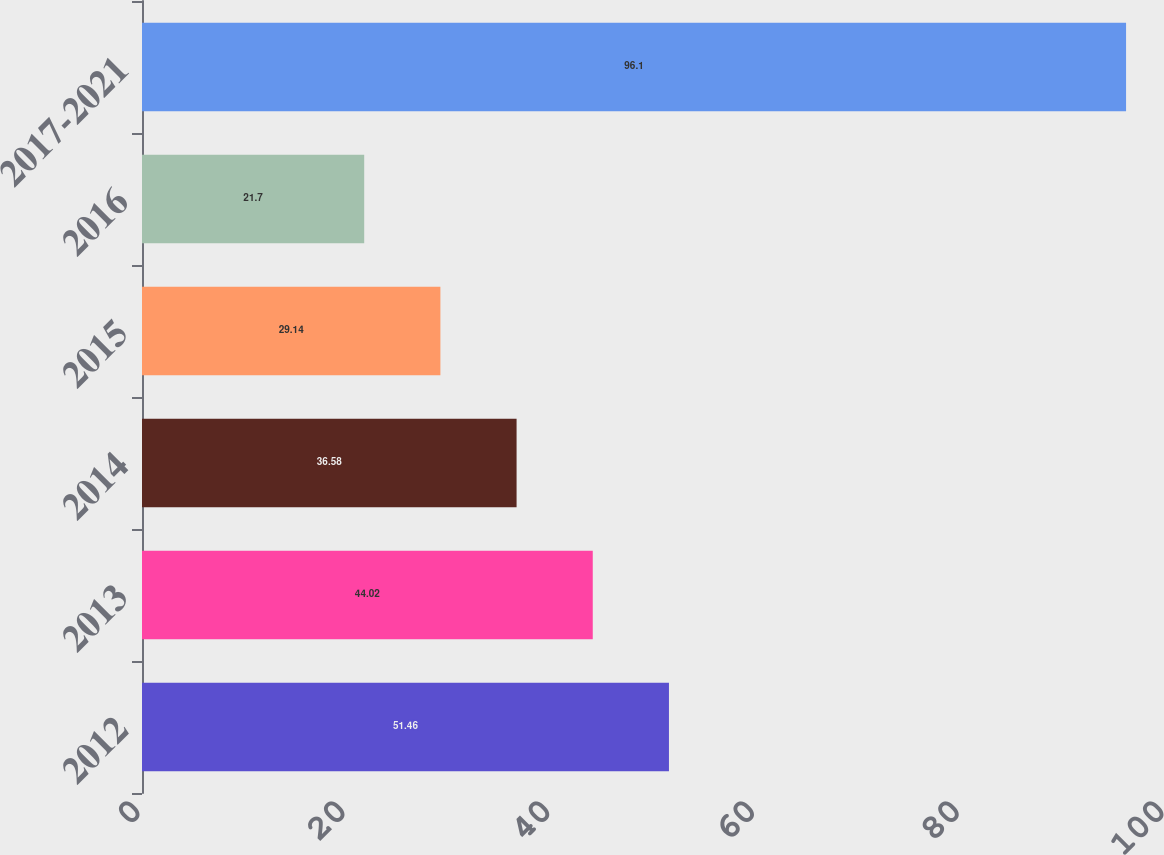Convert chart. <chart><loc_0><loc_0><loc_500><loc_500><bar_chart><fcel>2012<fcel>2013<fcel>2014<fcel>2015<fcel>2016<fcel>2017-2021<nl><fcel>51.46<fcel>44.02<fcel>36.58<fcel>29.14<fcel>21.7<fcel>96.1<nl></chart> 